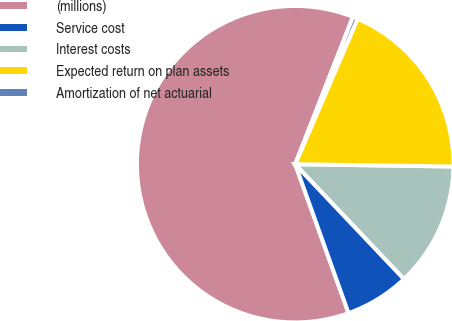<chart> <loc_0><loc_0><loc_500><loc_500><pie_chart><fcel>(millions)<fcel>Service cost<fcel>Interest costs<fcel>Expected return on plan assets<fcel>Amortization of net actuarial<nl><fcel>61.41%<fcel>6.6%<fcel>12.69%<fcel>18.78%<fcel>0.51%<nl></chart> 